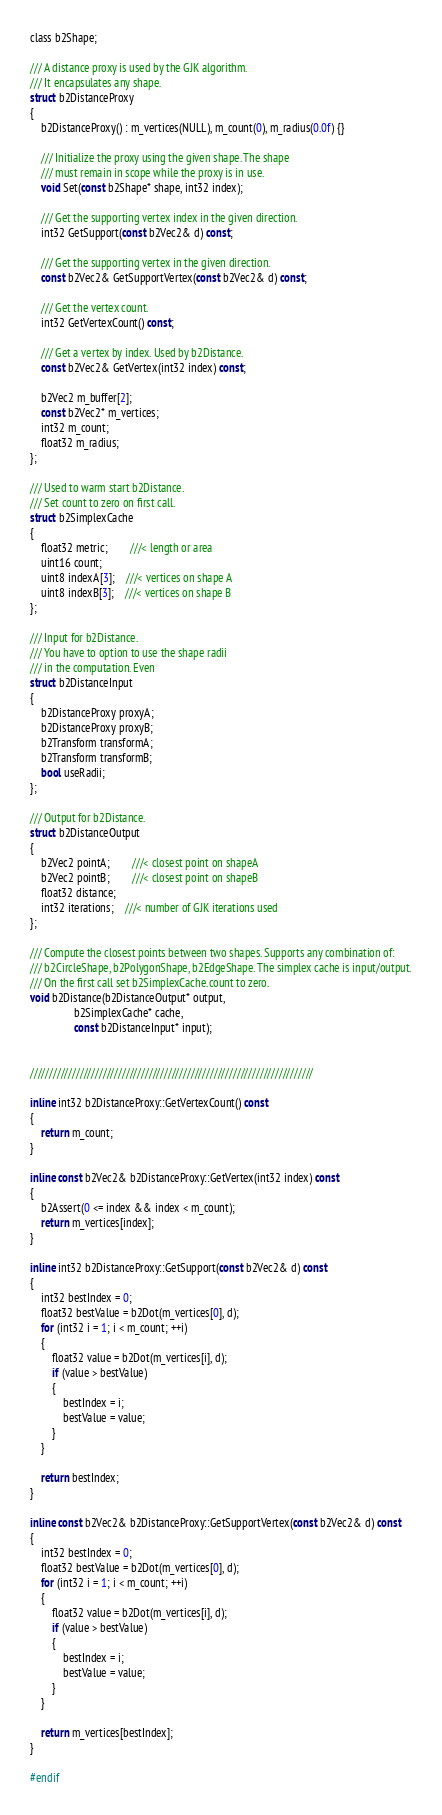<code> <loc_0><loc_0><loc_500><loc_500><_C_>
class b2Shape;

/// A distance proxy is used by the GJK algorithm.
/// It encapsulates any shape.
struct b2DistanceProxy
{
    b2DistanceProxy() : m_vertices(NULL), m_count(0), m_radius(0.0f) {}

    /// Initialize the proxy using the given shape. The shape
    /// must remain in scope while the proxy is in use.
    void Set(const b2Shape* shape, int32 index);

    /// Get the supporting vertex index in the given direction.
    int32 GetSupport(const b2Vec2& d) const;

    /// Get the supporting vertex in the given direction.
    const b2Vec2& GetSupportVertex(const b2Vec2& d) const;

    /// Get the vertex count.
    int32 GetVertexCount() const;

    /// Get a vertex by index. Used by b2Distance.
    const b2Vec2& GetVertex(int32 index) const;

    b2Vec2 m_buffer[2];
    const b2Vec2* m_vertices;
    int32 m_count;
    float32 m_radius;
};

/// Used to warm start b2Distance.
/// Set count to zero on first call.
struct b2SimplexCache
{
    float32 metric;        ///< length or area
    uint16 count;
    uint8 indexA[3];    ///< vertices on shape A
    uint8 indexB[3];    ///< vertices on shape B
};

/// Input for b2Distance.
/// You have to option to use the shape radii
/// in the computation. Even 
struct b2DistanceInput
{
    b2DistanceProxy proxyA;
    b2DistanceProxy proxyB;
    b2Transform transformA;
    b2Transform transformB;
    bool useRadii;
};

/// Output for b2Distance.
struct b2DistanceOutput
{
    b2Vec2 pointA;        ///< closest point on shapeA
    b2Vec2 pointB;        ///< closest point on shapeB
    float32 distance;
    int32 iterations;    ///< number of GJK iterations used
};

/// Compute the closest points between two shapes. Supports any combination of:
/// b2CircleShape, b2PolygonShape, b2EdgeShape. The simplex cache is input/output.
/// On the first call set b2SimplexCache.count to zero.
void b2Distance(b2DistanceOutput* output,
                b2SimplexCache* cache, 
                const b2DistanceInput* input);


//////////////////////////////////////////////////////////////////////////

inline int32 b2DistanceProxy::GetVertexCount() const
{
    return m_count;
}

inline const b2Vec2& b2DistanceProxy::GetVertex(int32 index) const
{
    b2Assert(0 <= index && index < m_count);
    return m_vertices[index];
}

inline int32 b2DistanceProxy::GetSupport(const b2Vec2& d) const
{
    int32 bestIndex = 0;
    float32 bestValue = b2Dot(m_vertices[0], d);
    for (int32 i = 1; i < m_count; ++i)
    {
        float32 value = b2Dot(m_vertices[i], d);
        if (value > bestValue)
        {
            bestIndex = i;
            bestValue = value;
        }
    }

    return bestIndex;
}

inline const b2Vec2& b2DistanceProxy::GetSupportVertex(const b2Vec2& d) const
{
    int32 bestIndex = 0;
    float32 bestValue = b2Dot(m_vertices[0], d);
    for (int32 i = 1; i < m_count; ++i)
    {
        float32 value = b2Dot(m_vertices[i], d);
        if (value > bestValue)
        {
            bestIndex = i;
            bestValue = value;
        }
    }

    return m_vertices[bestIndex];
}

#endif
</code> 